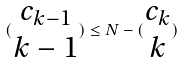<formula> <loc_0><loc_0><loc_500><loc_500>( \begin{matrix} c _ { k - 1 } \\ k - 1 \end{matrix} ) \leq N - ( \begin{matrix} c _ { k } \\ k \end{matrix} )</formula> 